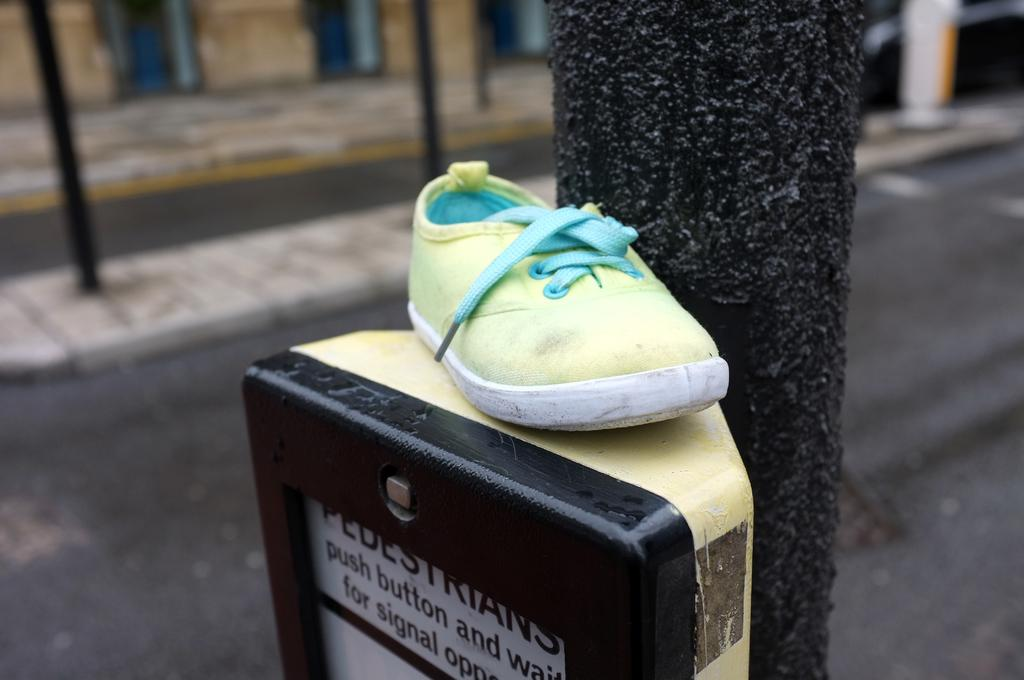What object is placed on a machine in the image? A: There is a shoe placed on a machine in the image. What is the machine attached to in the image? The machine is attached to a pole in the image. What can be seen in the background of the image? There are roads and a pathway visible in the background of the image. What type of dress is hanging on the board in the image? There is no dress or board present in the image. 